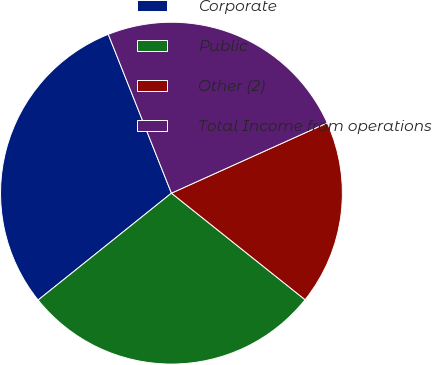<chart> <loc_0><loc_0><loc_500><loc_500><pie_chart><fcel>Corporate<fcel>Public<fcel>Other (2)<fcel>Total Income from operations<nl><fcel>29.73%<fcel>28.53%<fcel>17.46%<fcel>24.28%<nl></chart> 